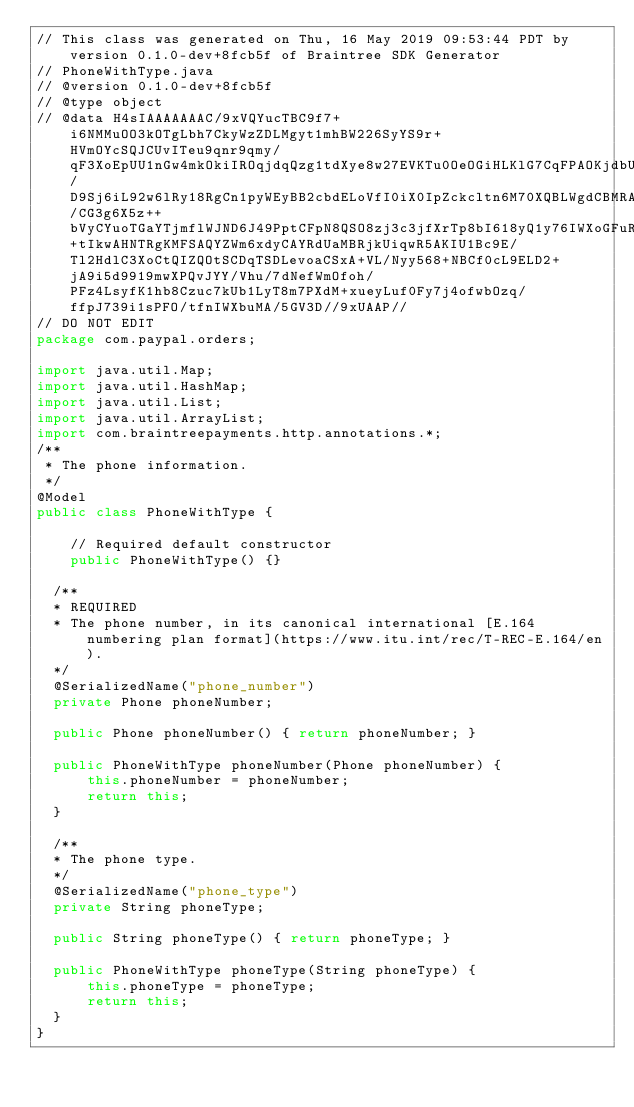<code> <loc_0><loc_0><loc_500><loc_500><_Java_>// This class was generated on Thu, 16 May 2019 09:53:44 PDT by version 0.1.0-dev+8fcb5f of Braintree SDK Generator
// PhoneWithType.java
// @version 0.1.0-dev+8fcb5f
// @type object
// @data H4sIAAAAAAAC/9xVQYucTBC9f7+i6NMMuOO3kOTgLbh7CkyWzZDLMgyt1mhBW226SyYS9r+HVmOYcSQJCUvITeu9qnr9qmy/qF3XoEpUU1nGw4mkOkiIROqjdqQzg1tdXye8w27EVKTu0OeOGiHLKlG7CqFPAOKjdbUO8Y2K1FvndDe0/D9Sj6iL92w6lRy18RgCn1pyWEyBB2cbdELoVfI0iX0IpZckcltn6M70XQBLWgdCBMRA4iHXbJlybYBY0HF/CG3g6X5z++bVyCYuoTGaYTjmflWJND6J49PptCFpN8QSO8zj3c3jfXrTp8bI618yQ1y76IWXoGFuRm5bFtcdcm0McXnIbXE+tIkwAHNTRgKMFSAQYZWm6xdyCAYRdUaMBRjkUiqwR5AKIU1Bc9E/Tl2HdlC3XoCtQIZQOtSCDqTSDLevoaCSxA+VL/Nyy568+NBCf0cL9ELD2+jA9i5d9919mwXPQvJYY/Vhu/7dNefWmOfoh/PFz4LsyfK1hb8Czuc7kUb1LyT8m7PXdM+xueyLuf0Fy7j4ofwbOzq/ffpJ739i1sPFO/tfnIWXbuMA/5GV3D//9xUAAP//
// DO NOT EDIT
package com.paypal.orders;

import java.util.Map;
import java.util.HashMap;
import java.util.List;
import java.util.ArrayList;
import com.braintreepayments.http.annotations.*;
/**
 * The phone information.
 */
@Model
public class PhoneWithType {

    // Required default constructor
    public PhoneWithType() {}

	/**
	* REQUIRED
	* The phone number, in its canonical international [E.164 numbering plan format](https://www.itu.int/rec/T-REC-E.164/en).
	*/
	@SerializedName("phone_number")
	private Phone phoneNumber;

	public Phone phoneNumber() { return phoneNumber; }
	
	public PhoneWithType phoneNumber(Phone phoneNumber) {
	    this.phoneNumber = phoneNumber;
	    return this;
	}

	/**
	* The phone type.
	*/
	@SerializedName("phone_type")
	private String phoneType;

	public String phoneType() { return phoneType; }
	
	public PhoneWithType phoneType(String phoneType) {
	    this.phoneType = phoneType;
	    return this;
	}
}
</code> 